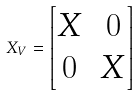Convert formula to latex. <formula><loc_0><loc_0><loc_500><loc_500>X _ { V } = \left [ \begin{matrix} X & 0 \\ 0 & X \end{matrix} \right ]</formula> 